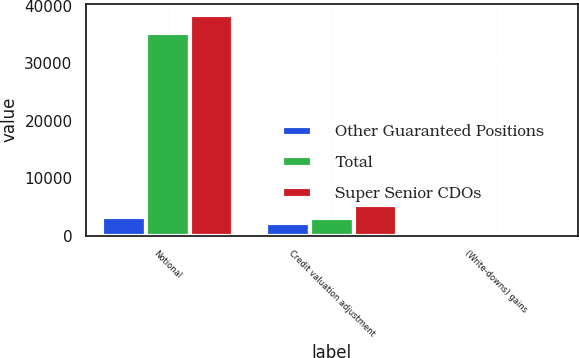Convert chart to OTSL. <chart><loc_0><loc_0><loc_500><loc_500><stacked_bar_chart><ecel><fcel>Notional<fcel>Credit valuation adjustment<fcel>(Write-downs) gains<nl><fcel>Other Guaranteed Positions<fcel>3241<fcel>2168<fcel>386<nl><fcel>Total<fcel>35183<fcel>3107<fcel>362<nl><fcel>Super Senior CDOs<fcel>38424<fcel>5275<fcel>24<nl></chart> 